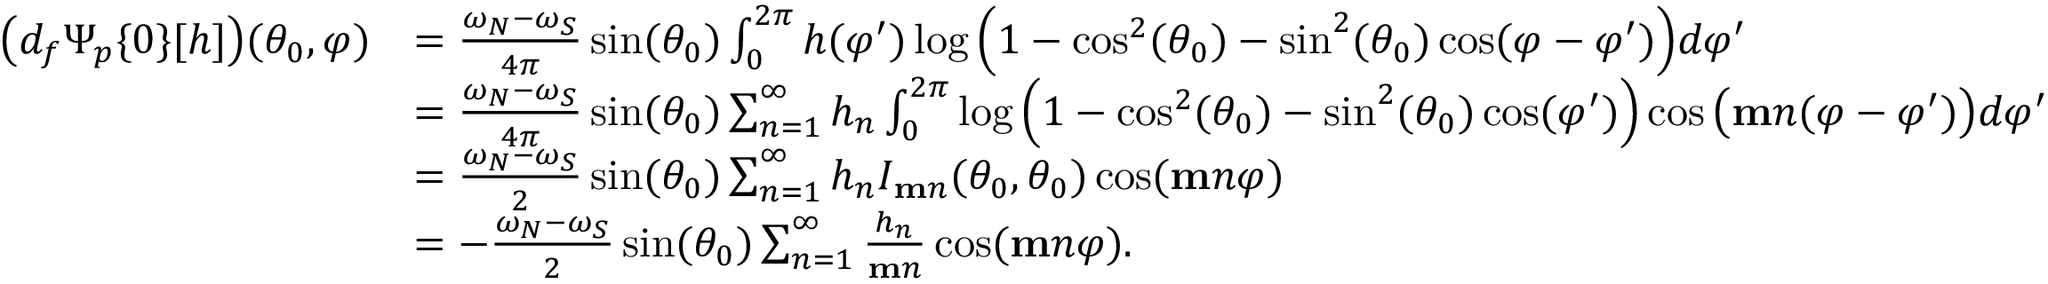Convert formula to latex. <formula><loc_0><loc_0><loc_500><loc_500>\begin{array} { r l } { \left ( d _ { f } \Psi _ { p } \{ 0 \} [ h ] \right ) ( \theta _ { 0 } , \varphi ) } & { = \frac { \omega _ { N } - \omega _ { S } } { 4 \pi } \sin ( \theta _ { 0 } ) \int _ { 0 } ^ { 2 \pi } h ( \varphi ^ { \prime } ) \log \left ( 1 - \cos ^ { 2 } ( \theta _ { 0 } ) - \sin ^ { 2 } ( \theta _ { 0 } ) \cos ( \varphi - \varphi ^ { \prime } ) \right ) d \varphi ^ { \prime } } \\ & { = \frac { \omega _ { N } - \omega _ { S } } { 4 \pi } \sin ( \theta _ { 0 } ) \sum _ { n = 1 } ^ { \infty } h _ { n } \int _ { 0 } ^ { 2 \pi } \log \left ( 1 - \cos ^ { 2 } ( \theta _ { 0 } ) - \sin ^ { 2 } ( \theta _ { 0 } ) \cos ( \varphi ^ { \prime } ) \right ) \cos \left ( m n ( \varphi - \varphi ^ { \prime } ) \right ) d \varphi ^ { \prime } } \\ & { = \frac { \omega _ { N } - \omega _ { S } } { 2 } \sin ( \theta _ { 0 } ) \sum _ { n = 1 } ^ { \infty } h _ { n } I _ { m n } ( \theta _ { 0 } , \theta _ { 0 } ) \cos ( m n \varphi ) } \\ & { = - \frac { \omega _ { N } - \omega _ { S } } { 2 } \sin ( \theta _ { 0 } ) \sum _ { n = 1 } ^ { \infty } \frac { h _ { n } } { m n } \cos ( m n \varphi ) . } \end{array}</formula> 